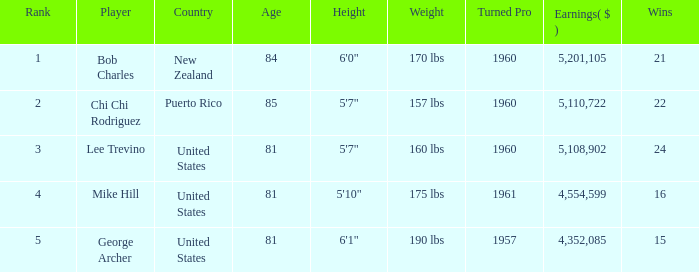In total, how much did the United States player George Archer earn with Wins lower than 24 and a rank that was higher than 5? 0.0. 